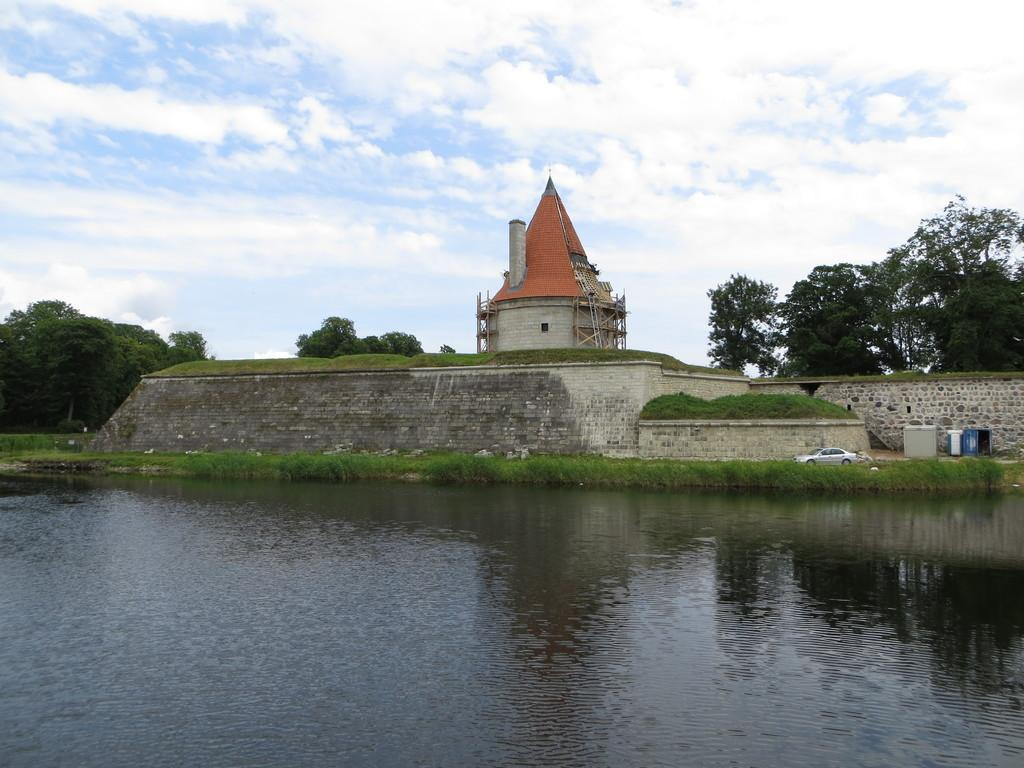What is present at the bottom of the image? There is water at the bottom of the image. What can be seen in the background of the image? There is a building and trees in the background of the image. Where is the car located in the image? The car is on the right side of the image. What is visible in the sky at the top of the image? There are clouds visible in the sky at the top of the image. What type of church can be seen burning in the image? There is no church present in the image, nor is anything burning. 